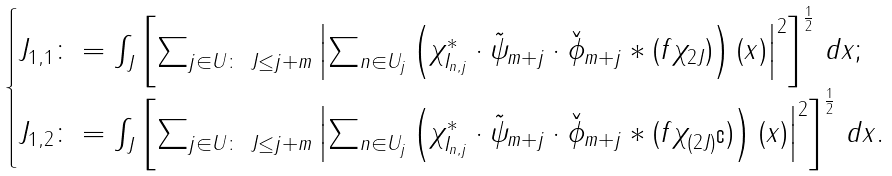<formula> <loc_0><loc_0><loc_500><loc_500>\begin{cases} J _ { 1 , 1 } \colon = \int _ { J } \left [ \sum _ { j \in U \colon \ J \leq j + m } \left | \sum _ { n \in U _ { j } } \left ( \chi ^ { * } _ { I _ { n , j } } \cdot \tilde { \psi } _ { m + j } \cdot \check { \phi } _ { m + j } \ast ( f \chi _ { 2 J } ) \right ) ( x ) \right | ^ { 2 } \right ] ^ { \frac { 1 } { 2 } } \, d x ; \\ J _ { 1 , 2 } \colon = \int _ { J } \left [ \sum _ { j \in U \colon \ J \leq j + m } \left | \sum _ { n \in U _ { j } } \left ( \chi ^ { * } _ { I _ { n , j } } \cdot \tilde { \psi } _ { m + j } \cdot \check { \phi } _ { m + j } \ast ( f \chi _ { ( 2 J ) ^ { \complement } } ) \right ) ( x ) \right | ^ { 2 } \right ] ^ { \frac { 1 } { 2 } } \, d x . \end{cases}</formula> 